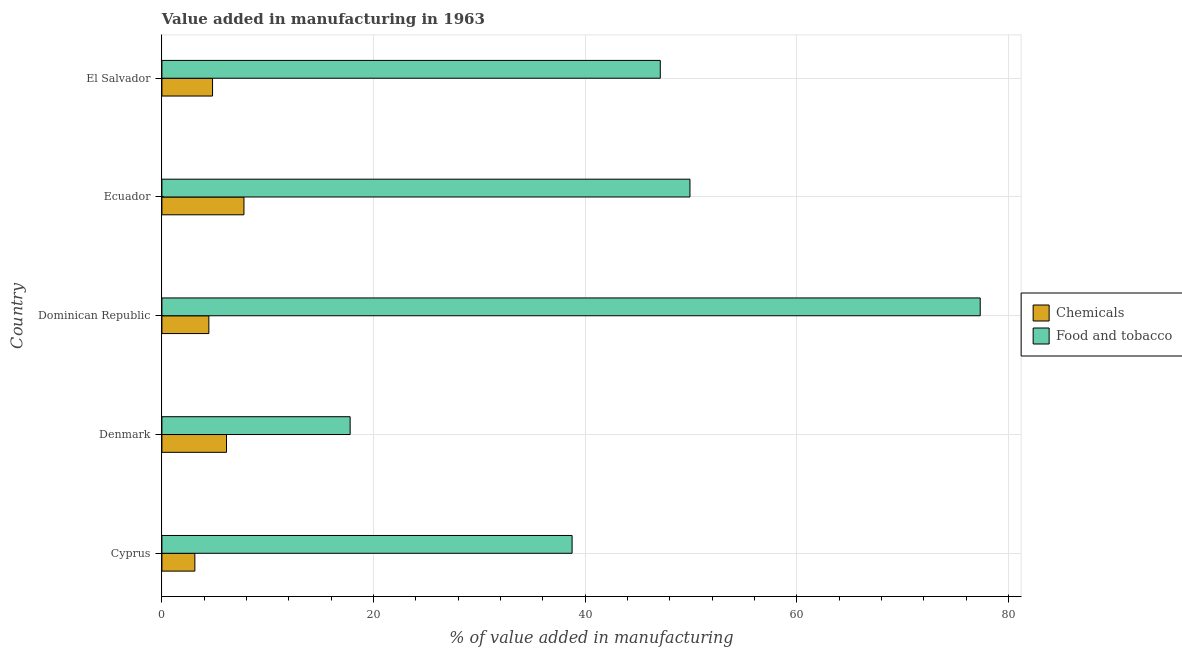How many different coloured bars are there?
Your response must be concise. 2. What is the label of the 3rd group of bars from the top?
Your answer should be very brief. Dominican Republic. What is the value added by manufacturing food and tobacco in Cyprus?
Your response must be concise. 38.75. Across all countries, what is the maximum value added by manufacturing food and tobacco?
Offer a terse response. 77.31. Across all countries, what is the minimum value added by manufacturing food and tobacco?
Offer a very short reply. 17.79. In which country was the value added by manufacturing food and tobacco maximum?
Your response must be concise. Dominican Republic. In which country was the value added by manufacturing food and tobacco minimum?
Provide a succinct answer. Denmark. What is the total value added by manufacturing food and tobacco in the graph?
Keep it short and to the point. 230.83. What is the difference between the value added by  manufacturing chemicals in Cyprus and that in Denmark?
Your answer should be very brief. -2.99. What is the difference between the value added by manufacturing food and tobacco in Ecuador and the value added by  manufacturing chemicals in El Salvador?
Your answer should be compact. 45.11. What is the average value added by  manufacturing chemicals per country?
Make the answer very short. 5.24. What is the difference between the value added by manufacturing food and tobacco and value added by  manufacturing chemicals in Denmark?
Give a very brief answer. 11.68. What is the ratio of the value added by manufacturing food and tobacco in Dominican Republic to that in El Salvador?
Your answer should be compact. 1.64. Is the value added by  manufacturing chemicals in Dominican Republic less than that in El Salvador?
Your response must be concise. Yes. What is the difference between the highest and the second highest value added by manufacturing food and tobacco?
Your answer should be very brief. 27.42. What is the difference between the highest and the lowest value added by  manufacturing chemicals?
Provide a short and direct response. 4.64. What does the 2nd bar from the top in Ecuador represents?
Offer a terse response. Chemicals. What does the 2nd bar from the bottom in Ecuador represents?
Provide a succinct answer. Food and tobacco. How many bars are there?
Provide a succinct answer. 10. How many countries are there in the graph?
Offer a very short reply. 5. Does the graph contain any zero values?
Give a very brief answer. No. Does the graph contain grids?
Ensure brevity in your answer.  Yes. How many legend labels are there?
Give a very brief answer. 2. What is the title of the graph?
Ensure brevity in your answer.  Value added in manufacturing in 1963. What is the label or title of the X-axis?
Offer a very short reply. % of value added in manufacturing. What is the label or title of the Y-axis?
Your response must be concise. Country. What is the % of value added in manufacturing in Chemicals in Cyprus?
Provide a short and direct response. 3.11. What is the % of value added in manufacturing in Food and tobacco in Cyprus?
Your answer should be very brief. 38.75. What is the % of value added in manufacturing of Chemicals in Denmark?
Your answer should be compact. 6.1. What is the % of value added in manufacturing of Food and tobacco in Denmark?
Your answer should be compact. 17.79. What is the % of value added in manufacturing in Chemicals in Dominican Republic?
Offer a very short reply. 4.44. What is the % of value added in manufacturing of Food and tobacco in Dominican Republic?
Ensure brevity in your answer.  77.31. What is the % of value added in manufacturing of Chemicals in Ecuador?
Keep it short and to the point. 7.75. What is the % of value added in manufacturing of Food and tobacco in Ecuador?
Ensure brevity in your answer.  49.89. What is the % of value added in manufacturing of Chemicals in El Salvador?
Make the answer very short. 4.78. What is the % of value added in manufacturing of Food and tobacco in El Salvador?
Offer a terse response. 47.09. Across all countries, what is the maximum % of value added in manufacturing of Chemicals?
Offer a very short reply. 7.75. Across all countries, what is the maximum % of value added in manufacturing of Food and tobacco?
Your answer should be compact. 77.31. Across all countries, what is the minimum % of value added in manufacturing of Chemicals?
Offer a very short reply. 3.11. Across all countries, what is the minimum % of value added in manufacturing of Food and tobacco?
Offer a terse response. 17.79. What is the total % of value added in manufacturing of Chemicals in the graph?
Keep it short and to the point. 26.19. What is the total % of value added in manufacturing of Food and tobacco in the graph?
Offer a terse response. 230.83. What is the difference between the % of value added in manufacturing in Chemicals in Cyprus and that in Denmark?
Provide a short and direct response. -2.99. What is the difference between the % of value added in manufacturing of Food and tobacco in Cyprus and that in Denmark?
Offer a terse response. 20.97. What is the difference between the % of value added in manufacturing of Chemicals in Cyprus and that in Dominican Republic?
Make the answer very short. -1.32. What is the difference between the % of value added in manufacturing of Food and tobacco in Cyprus and that in Dominican Republic?
Make the answer very short. -38.56. What is the difference between the % of value added in manufacturing of Chemicals in Cyprus and that in Ecuador?
Give a very brief answer. -4.64. What is the difference between the % of value added in manufacturing of Food and tobacco in Cyprus and that in Ecuador?
Your answer should be very brief. -11.14. What is the difference between the % of value added in manufacturing of Chemicals in Cyprus and that in El Salvador?
Your response must be concise. -1.67. What is the difference between the % of value added in manufacturing of Food and tobacco in Cyprus and that in El Salvador?
Your response must be concise. -8.33. What is the difference between the % of value added in manufacturing in Chemicals in Denmark and that in Dominican Republic?
Offer a terse response. 1.67. What is the difference between the % of value added in manufacturing of Food and tobacco in Denmark and that in Dominican Republic?
Offer a terse response. -59.53. What is the difference between the % of value added in manufacturing of Chemicals in Denmark and that in Ecuador?
Your response must be concise. -1.65. What is the difference between the % of value added in manufacturing in Food and tobacco in Denmark and that in Ecuador?
Keep it short and to the point. -32.11. What is the difference between the % of value added in manufacturing of Chemicals in Denmark and that in El Salvador?
Ensure brevity in your answer.  1.32. What is the difference between the % of value added in manufacturing of Food and tobacco in Denmark and that in El Salvador?
Your answer should be very brief. -29.3. What is the difference between the % of value added in manufacturing of Chemicals in Dominican Republic and that in Ecuador?
Your answer should be very brief. -3.32. What is the difference between the % of value added in manufacturing in Food and tobacco in Dominican Republic and that in Ecuador?
Your answer should be very brief. 27.42. What is the difference between the % of value added in manufacturing in Chemicals in Dominican Republic and that in El Salvador?
Keep it short and to the point. -0.35. What is the difference between the % of value added in manufacturing of Food and tobacco in Dominican Republic and that in El Salvador?
Provide a short and direct response. 30.23. What is the difference between the % of value added in manufacturing in Chemicals in Ecuador and that in El Salvador?
Make the answer very short. 2.97. What is the difference between the % of value added in manufacturing of Food and tobacco in Ecuador and that in El Salvador?
Provide a short and direct response. 2.81. What is the difference between the % of value added in manufacturing of Chemicals in Cyprus and the % of value added in manufacturing of Food and tobacco in Denmark?
Your answer should be compact. -14.67. What is the difference between the % of value added in manufacturing of Chemicals in Cyprus and the % of value added in manufacturing of Food and tobacco in Dominican Republic?
Provide a succinct answer. -74.2. What is the difference between the % of value added in manufacturing of Chemicals in Cyprus and the % of value added in manufacturing of Food and tobacco in Ecuador?
Your response must be concise. -46.78. What is the difference between the % of value added in manufacturing of Chemicals in Cyprus and the % of value added in manufacturing of Food and tobacco in El Salvador?
Provide a short and direct response. -43.97. What is the difference between the % of value added in manufacturing of Chemicals in Denmark and the % of value added in manufacturing of Food and tobacco in Dominican Republic?
Your answer should be very brief. -71.21. What is the difference between the % of value added in manufacturing in Chemicals in Denmark and the % of value added in manufacturing in Food and tobacco in Ecuador?
Provide a succinct answer. -43.79. What is the difference between the % of value added in manufacturing in Chemicals in Denmark and the % of value added in manufacturing in Food and tobacco in El Salvador?
Your response must be concise. -40.98. What is the difference between the % of value added in manufacturing of Chemicals in Dominican Republic and the % of value added in manufacturing of Food and tobacco in Ecuador?
Keep it short and to the point. -45.46. What is the difference between the % of value added in manufacturing in Chemicals in Dominican Republic and the % of value added in manufacturing in Food and tobacco in El Salvador?
Your response must be concise. -42.65. What is the difference between the % of value added in manufacturing in Chemicals in Ecuador and the % of value added in manufacturing in Food and tobacco in El Salvador?
Offer a very short reply. -39.33. What is the average % of value added in manufacturing in Chemicals per country?
Provide a short and direct response. 5.24. What is the average % of value added in manufacturing in Food and tobacco per country?
Your answer should be compact. 46.17. What is the difference between the % of value added in manufacturing of Chemicals and % of value added in manufacturing of Food and tobacco in Cyprus?
Offer a terse response. -35.64. What is the difference between the % of value added in manufacturing in Chemicals and % of value added in manufacturing in Food and tobacco in Denmark?
Give a very brief answer. -11.68. What is the difference between the % of value added in manufacturing in Chemicals and % of value added in manufacturing in Food and tobacco in Dominican Republic?
Keep it short and to the point. -72.88. What is the difference between the % of value added in manufacturing of Chemicals and % of value added in manufacturing of Food and tobacco in Ecuador?
Offer a terse response. -42.14. What is the difference between the % of value added in manufacturing in Chemicals and % of value added in manufacturing in Food and tobacco in El Salvador?
Ensure brevity in your answer.  -42.3. What is the ratio of the % of value added in manufacturing of Chemicals in Cyprus to that in Denmark?
Keep it short and to the point. 0.51. What is the ratio of the % of value added in manufacturing in Food and tobacco in Cyprus to that in Denmark?
Provide a succinct answer. 2.18. What is the ratio of the % of value added in manufacturing in Chemicals in Cyprus to that in Dominican Republic?
Keep it short and to the point. 0.7. What is the ratio of the % of value added in manufacturing in Food and tobacco in Cyprus to that in Dominican Republic?
Make the answer very short. 0.5. What is the ratio of the % of value added in manufacturing in Chemicals in Cyprus to that in Ecuador?
Offer a very short reply. 0.4. What is the ratio of the % of value added in manufacturing in Food and tobacco in Cyprus to that in Ecuador?
Provide a succinct answer. 0.78. What is the ratio of the % of value added in manufacturing of Chemicals in Cyprus to that in El Salvador?
Offer a very short reply. 0.65. What is the ratio of the % of value added in manufacturing of Food and tobacco in Cyprus to that in El Salvador?
Your response must be concise. 0.82. What is the ratio of the % of value added in manufacturing of Chemicals in Denmark to that in Dominican Republic?
Offer a terse response. 1.38. What is the ratio of the % of value added in manufacturing in Food and tobacco in Denmark to that in Dominican Republic?
Your answer should be very brief. 0.23. What is the ratio of the % of value added in manufacturing in Chemicals in Denmark to that in Ecuador?
Provide a short and direct response. 0.79. What is the ratio of the % of value added in manufacturing of Food and tobacco in Denmark to that in Ecuador?
Ensure brevity in your answer.  0.36. What is the ratio of the % of value added in manufacturing in Chemicals in Denmark to that in El Salvador?
Make the answer very short. 1.28. What is the ratio of the % of value added in manufacturing of Food and tobacco in Denmark to that in El Salvador?
Offer a terse response. 0.38. What is the ratio of the % of value added in manufacturing of Chemicals in Dominican Republic to that in Ecuador?
Keep it short and to the point. 0.57. What is the ratio of the % of value added in manufacturing of Food and tobacco in Dominican Republic to that in Ecuador?
Provide a succinct answer. 1.55. What is the ratio of the % of value added in manufacturing of Chemicals in Dominican Republic to that in El Salvador?
Your answer should be very brief. 0.93. What is the ratio of the % of value added in manufacturing in Food and tobacco in Dominican Republic to that in El Salvador?
Ensure brevity in your answer.  1.64. What is the ratio of the % of value added in manufacturing of Chemicals in Ecuador to that in El Salvador?
Your response must be concise. 1.62. What is the ratio of the % of value added in manufacturing in Food and tobacco in Ecuador to that in El Salvador?
Provide a succinct answer. 1.06. What is the difference between the highest and the second highest % of value added in manufacturing in Chemicals?
Offer a terse response. 1.65. What is the difference between the highest and the second highest % of value added in manufacturing of Food and tobacco?
Your answer should be compact. 27.42. What is the difference between the highest and the lowest % of value added in manufacturing in Chemicals?
Offer a very short reply. 4.64. What is the difference between the highest and the lowest % of value added in manufacturing in Food and tobacco?
Provide a succinct answer. 59.53. 